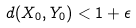<formula> <loc_0><loc_0><loc_500><loc_500>d ( X _ { 0 } , Y _ { 0 } ) < 1 + \epsilon</formula> 